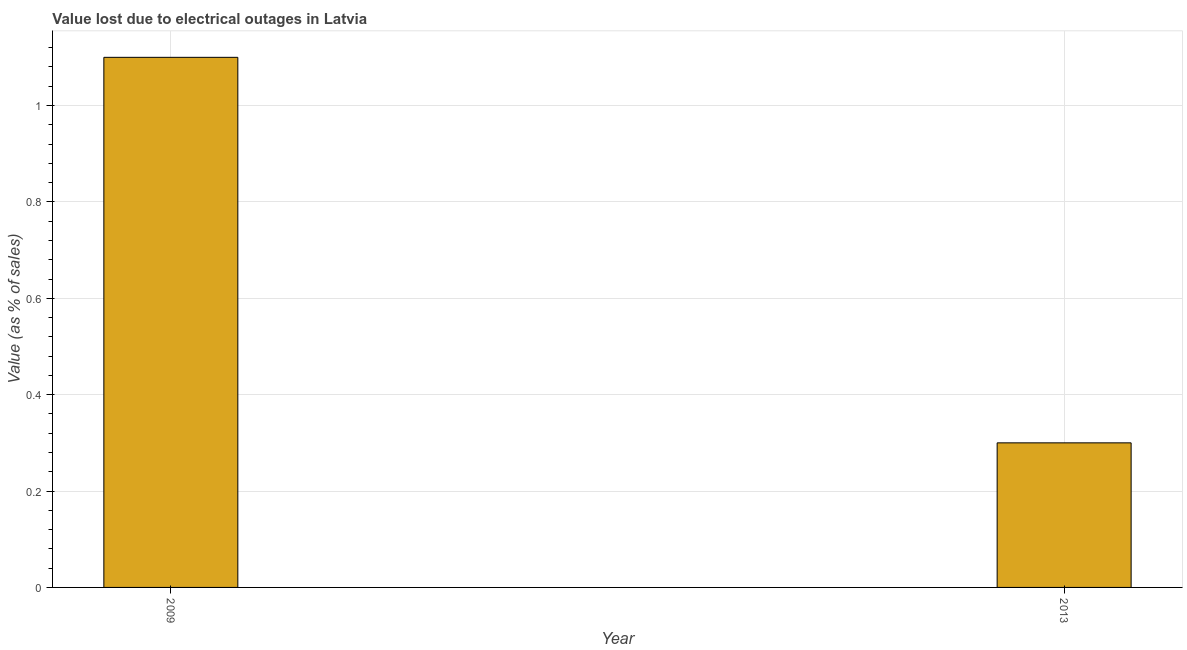What is the title of the graph?
Offer a very short reply. Value lost due to electrical outages in Latvia. What is the label or title of the Y-axis?
Offer a very short reply. Value (as % of sales). What is the sum of the value lost due to electrical outages?
Give a very brief answer. 1.4. What is the difference between the value lost due to electrical outages in 2009 and 2013?
Offer a very short reply. 0.8. What is the average value lost due to electrical outages per year?
Offer a terse response. 0.7. What is the median value lost due to electrical outages?
Offer a very short reply. 0.7. Do a majority of the years between 2009 and 2013 (inclusive) have value lost due to electrical outages greater than 0.6 %?
Provide a short and direct response. No. What is the ratio of the value lost due to electrical outages in 2009 to that in 2013?
Ensure brevity in your answer.  3.67. Is the value lost due to electrical outages in 2009 less than that in 2013?
Keep it short and to the point. No. Are all the bars in the graph horizontal?
Give a very brief answer. No. How many years are there in the graph?
Your answer should be compact. 2. What is the difference between two consecutive major ticks on the Y-axis?
Offer a terse response. 0.2. Are the values on the major ticks of Y-axis written in scientific E-notation?
Your answer should be very brief. No. What is the Value (as % of sales) of 2009?
Your answer should be very brief. 1.1. What is the difference between the Value (as % of sales) in 2009 and 2013?
Ensure brevity in your answer.  0.8. What is the ratio of the Value (as % of sales) in 2009 to that in 2013?
Your answer should be compact. 3.67. 